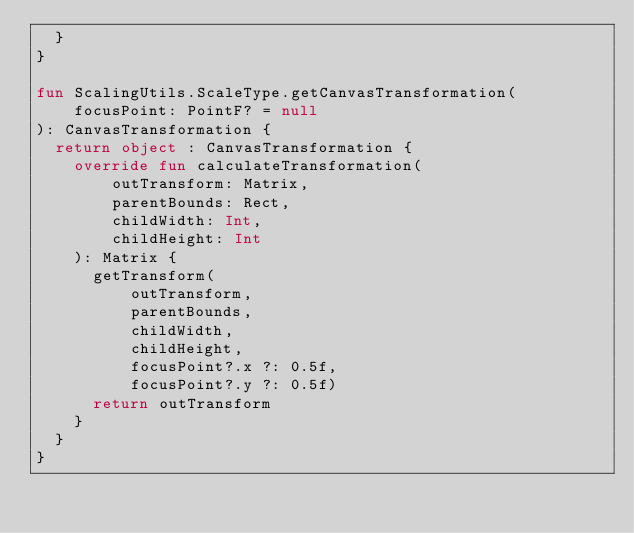Convert code to text. <code><loc_0><loc_0><loc_500><loc_500><_Kotlin_>  }
}

fun ScalingUtils.ScaleType.getCanvasTransformation(
    focusPoint: PointF? = null
): CanvasTransformation {
  return object : CanvasTransformation {
    override fun calculateTransformation(
        outTransform: Matrix,
        parentBounds: Rect,
        childWidth: Int,
        childHeight: Int
    ): Matrix {
      getTransform(
          outTransform,
          parentBounds,
          childWidth,
          childHeight,
          focusPoint?.x ?: 0.5f,
          focusPoint?.y ?: 0.5f)
      return outTransform
    }
  }
}
</code> 